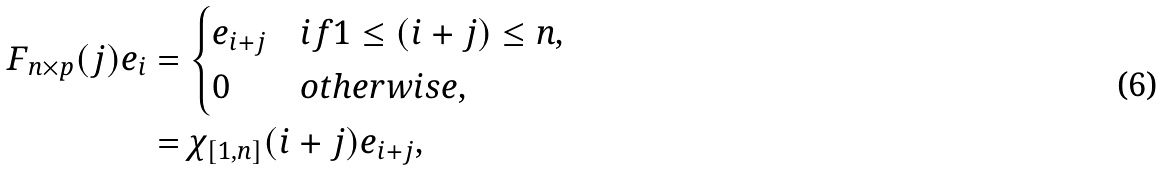<formula> <loc_0><loc_0><loc_500><loc_500>F _ { n \times p } { ( j ) } e _ { i } & = \begin{cases} e _ { i + j } & i f 1 \leq ( i + j ) \leq n , \\ 0 & o t h e r w i s e , \end{cases} \\ & = \chi _ { [ 1 , n ] } ( i + j ) e _ { i + j } ,</formula> 